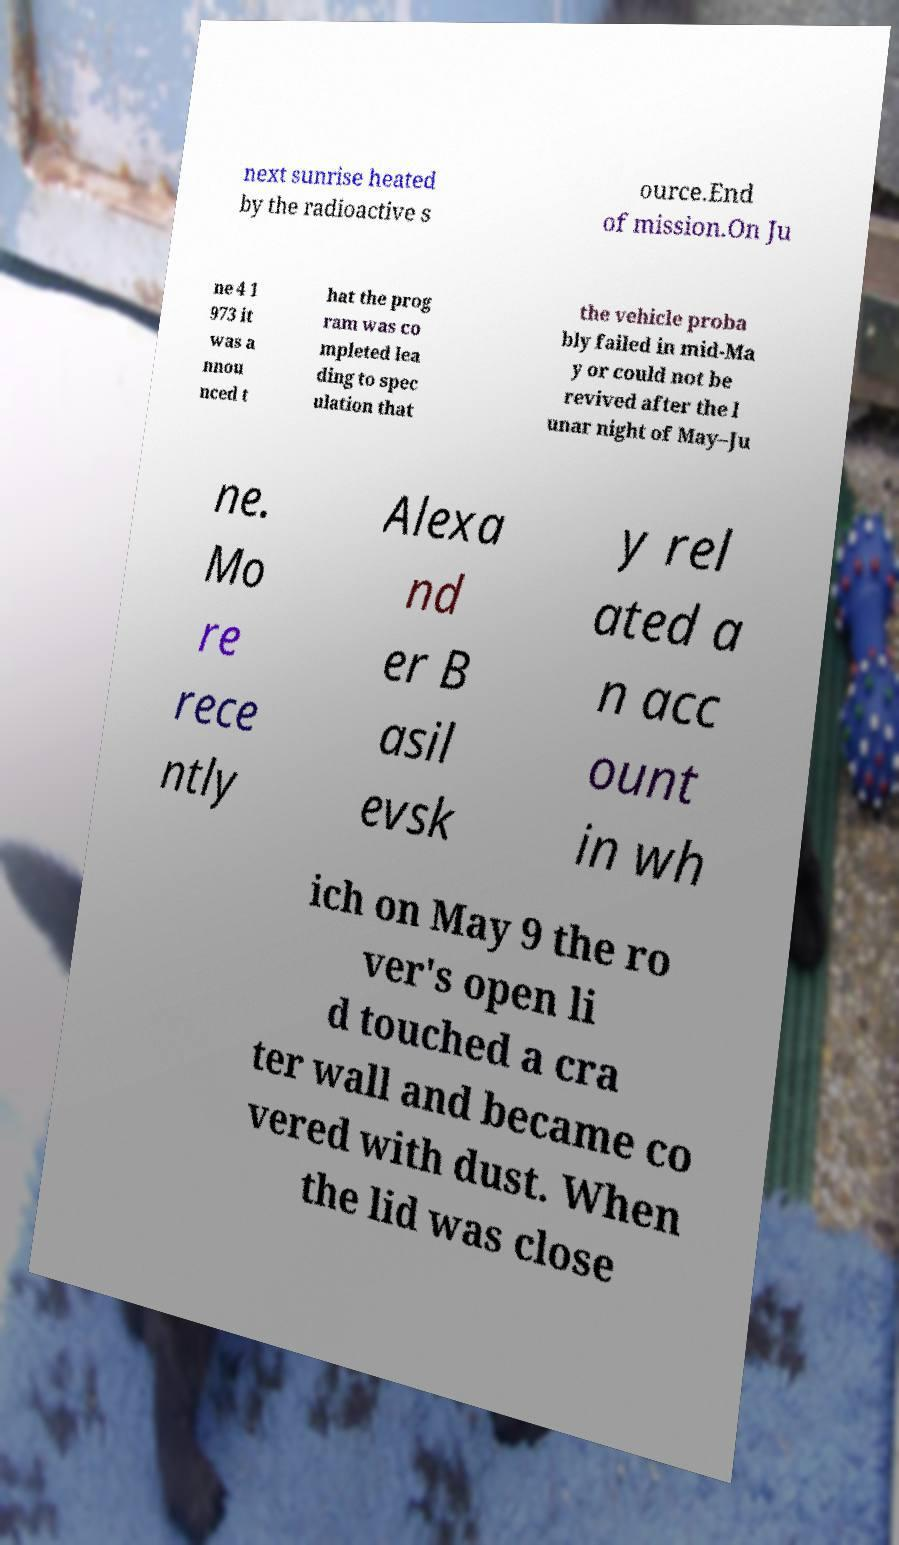Can you accurately transcribe the text from the provided image for me? next sunrise heated by the radioactive s ource.End of mission.On Ju ne 4 1 973 it was a nnou nced t hat the prog ram was co mpleted lea ding to spec ulation that the vehicle proba bly failed in mid-Ma y or could not be revived after the l unar night of May–Ju ne. Mo re rece ntly Alexa nd er B asil evsk y rel ated a n acc ount in wh ich on May 9 the ro ver's open li d touched a cra ter wall and became co vered with dust. When the lid was close 